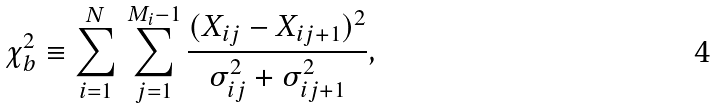<formula> <loc_0><loc_0><loc_500><loc_500>\chi ^ { 2 } _ { b } \equiv \sum _ { i = 1 } ^ { N } \, \sum _ { j = 1 } ^ { M _ { i } - 1 } \frac { ( X _ { i j } - X _ { i j + 1 } ) ^ { 2 } } { \sigma ^ { 2 } _ { i j } + \sigma ^ { 2 } _ { i j + 1 } } ,</formula> 